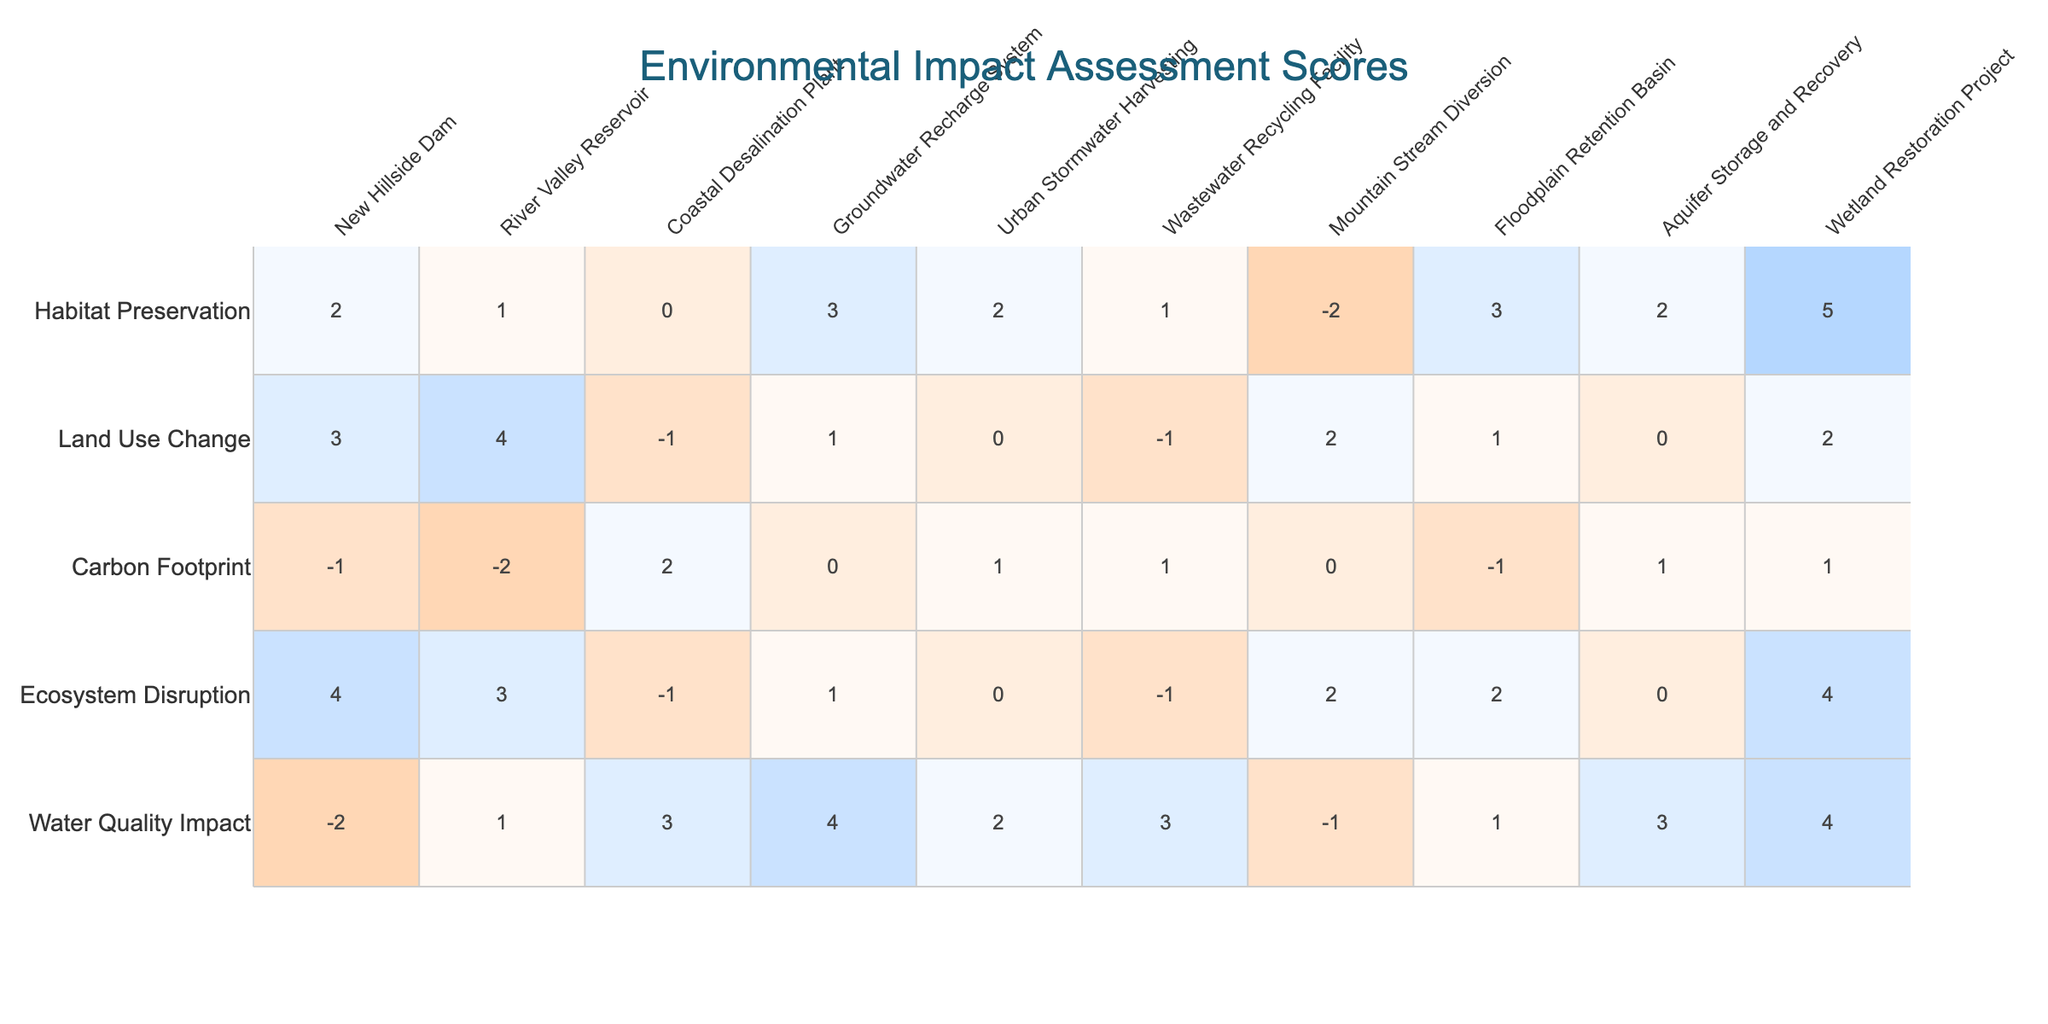What is the water quality impact score for the Coastal Desalination Plant? Referring to the table, the water quality impact score for the Coastal Desalination Plant is 3.
Answer: 3 Which project has the highest score for habitat preservation? By checking the habitat preservation scores, the Wetland Restoration Project has the highest score of 5.
Answer: 5 What is the average carbon footprint score of all projects? The carbon footprint scores are: -1, -2, 2, 0, 1, 1, 0, -1, 1, 1. Summing them gives us (-1 - 2 + 2 + 0 + 1 + 1 + 0 - 1 + 1 + 1 = 2). There are 10 projects, so the average is 2/10 = 0.2.
Answer: 0.2 Does the Mountain Stream Diversion project have a negative land use change score? The land use change score for the Mountain Stream Diversion is 2, which is not negative.
Answer: No Which project shows the least ecosystem disruption? Looking at the ecosystem disruption scores, the Coastal Desalination Plant has a score of -1, which is the least among all projects.
Answer: Coastal Desalination Plant What is the total score for land use change across all projects? The land use change scores are: 3, 4, -1, 1, 0, -1, 2, 1, 0, 2. Adding these scores gives us (3 + 4 - 1 + 1 + 0 - 1 + 2 + 1 + 0 + 2 = 11).
Answer: 11 Identify any project with a negative score for habitat preservation. Checking the habitat preservation scores, only the Mountain Stream Diversion project has a negative score of -2.
Answer: Yes, Mountain Stream Diversion Which project has a water quality impact score greater than 0 and a low ecosystem disruption score? The Groundwater Recharge System has a water quality impact score of 4 (greater than 0) and an ecosystem disruption score of 1 (low).
Answer: Groundwater Recharge System What is the difference between the highest and lowest ecosystem disruption scores? The highest ecosystem disruption score is 4 (Wetland Restoration Project), and the lowest is -1 (Coastal Desalination Plant). The difference is 4 - (-1) = 5.
Answer: 5 Which two projects have the same water quality impact score? By analyzing the water quality impact scores, the Wastewater Recycling Facility and Coastal Desalination Plant both have a score of 3.
Answer: Wastewater Recycling Facility and Coastal Desalination Plant What is the overall trend for land use change among these projects? The land use change scores show a mix of positive and negative values, indicating that there is no clear overall trend; scores range from -1 to 4.
Answer: Mixed, no clear trend 